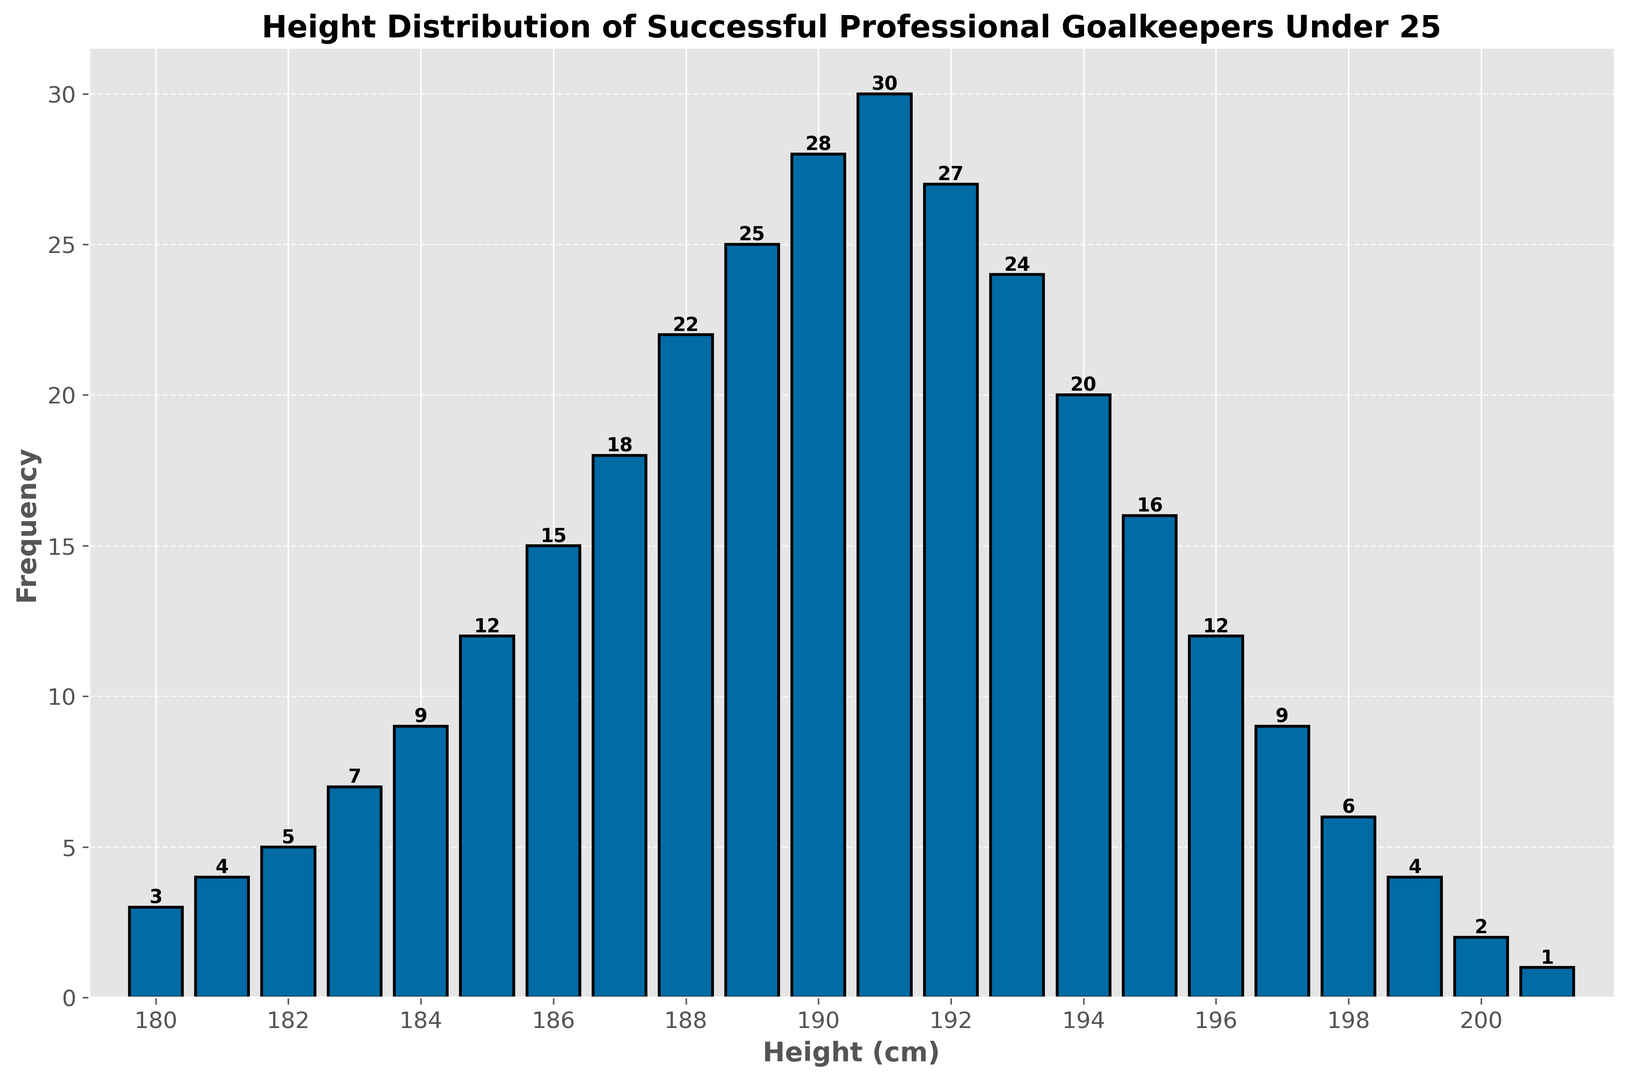what is the most common height range of goalkeepers under 25? The most frequent height is identified by the tallest bar in the histogram. The height range can be seen visually, with the bar for 191 cm having the highest frequency.
Answer: 191 cm what is the total number of successful goalkeepers under 25 measured in this analysis? To find the total number of goalkeepers, sum up the frequencies for all height categories. The total is 3 + 4 + 5 + 7 + 9 + 12 + 15 + 18 + 22 + 25 + 28 + 30 + 27 + 24 + 20 + 16 + 12 + 9 + 6 + 4 + 2 + 1, resulting in 299.
Answer: 299 Between which heights do the majority of goalkeepers fall? The majority often refers to over half the total frequency. Identify where the significant frequencies happen by summing the values around the peak. Goalkeepers mainly fall between 184 cm to 196 cm.
Answer: 184 cm to 196 cm How many goalkeepers are there above 195 cm? Sum the frequencies of all height categories greater than 195 cm (195 cm not included). Specifically, these are 196 cm, 197 cm, 198 cm, 199 cm, 200 cm, and 201 cm, resulting in 12 + 9 + 6 + 4 + 2 + 1 = 34.
Answer: 34 Which height has exactly 22 successful goalkeepers under 25? Identify the height corresponding to the frequency of 22 in the histogram. The height with a frequency of 22 is 188 cm.
Answer: 188 cm How many goalkeepers are shorter than 185 cm? Sum the frequencies of all height categories less than 185 cm. These are: 180, 181, 182, 183, and 184 cm, which are 3 + 4 + 5 + 7 + 9 = 28.
Answer: 28 How does the number of goalkeepers at 190 cm compare to the number at 195 cm? Identify the frequencies for 190 cm and 195 cm in the histogram. There are 28 goalkeepers at 190 cm and 16 at 195 cm. 190 cm has more goalkeepers.
Answer: More at 190 cm What height range has the least frequency and what is it? Identify the shortest bar in the histogram. The height range with the least frequency is 201 cm, with a frequency of 1.
Answer: 201 cm Is there a noticeable trend in the frequency of goalkeepers as height increases from 180 cm to 191 cm? Observe the histogram from 180 cm to 191 cm. The trend shows a gradual increase in frequency up to 191 cm.
Answer: Increasing trend Which height range between 186 cm and 189 cm has the highest frequency? Compare the frequencies within this range visually. The height range 189 cm has the highest frequency within this range.
Answer: 189 cm 